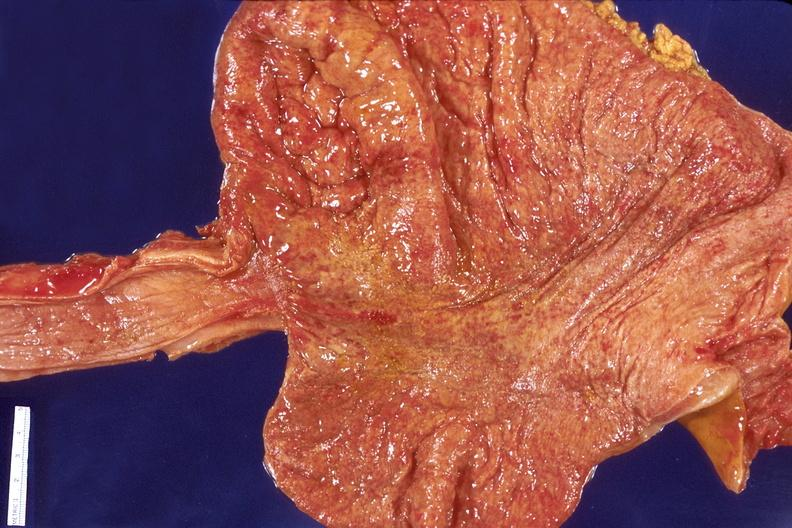does child show stomach, bacterial gastritis?
Answer the question using a single word or phrase. No 